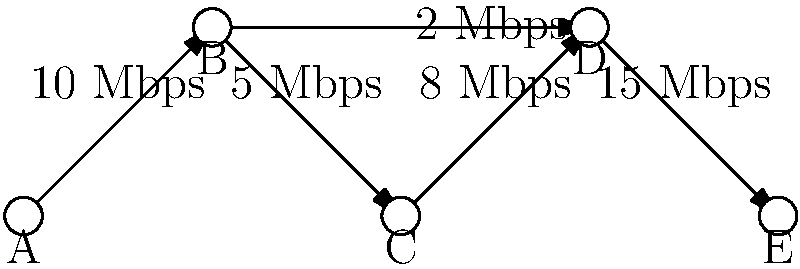As you review the network topology diagram for our company's new project, you notice a potential bottleneck. Which connection in this network is most likely to become a bottleneck, and how might this impact our new team member's work? To identify the bottleneck in this network topology, we need to analyze the bandwidth of each connection:

1. A to B: 10 Mbps
2. B to C: 5 Mbps
3. C to D: 8 Mbps
4. D to E: 15 Mbps
5. B to D: 2 Mbps

Step 1: Identify the lowest bandwidth connection
The connection with the lowest bandwidth is B to D at 2 Mbps.

Step 2: Consider the network flow
Data flowing from A to E has two possible paths:
Path 1: A -> B -> C -> D -> E
Path 2: A -> B -> D -> E

Step 3: Analyze the impact
The 2 Mbps connection between B and D is significantly slower than the other connections. This means:
- Path 2 will be limited to 2 Mbps, making it slower than Path 1.
- Even for Path 1, the 2 Mbps connection can cause congestion if B needs to send data to D.

Step 4: Consider the impact on the new team member
The new hire may experience:
- Slow file transfers when accessing resources on the other side of this connection.
- Delayed responses in applications that rely on data passing through this link.
- Potential issues with real-time communication tools if they cross this connection.

Therefore, the 2 Mbps connection between B and D is the most likely bottleneck, potentially causing frustration and reduced productivity for the new team member.
Answer: The 2 Mbps connection between B and D 